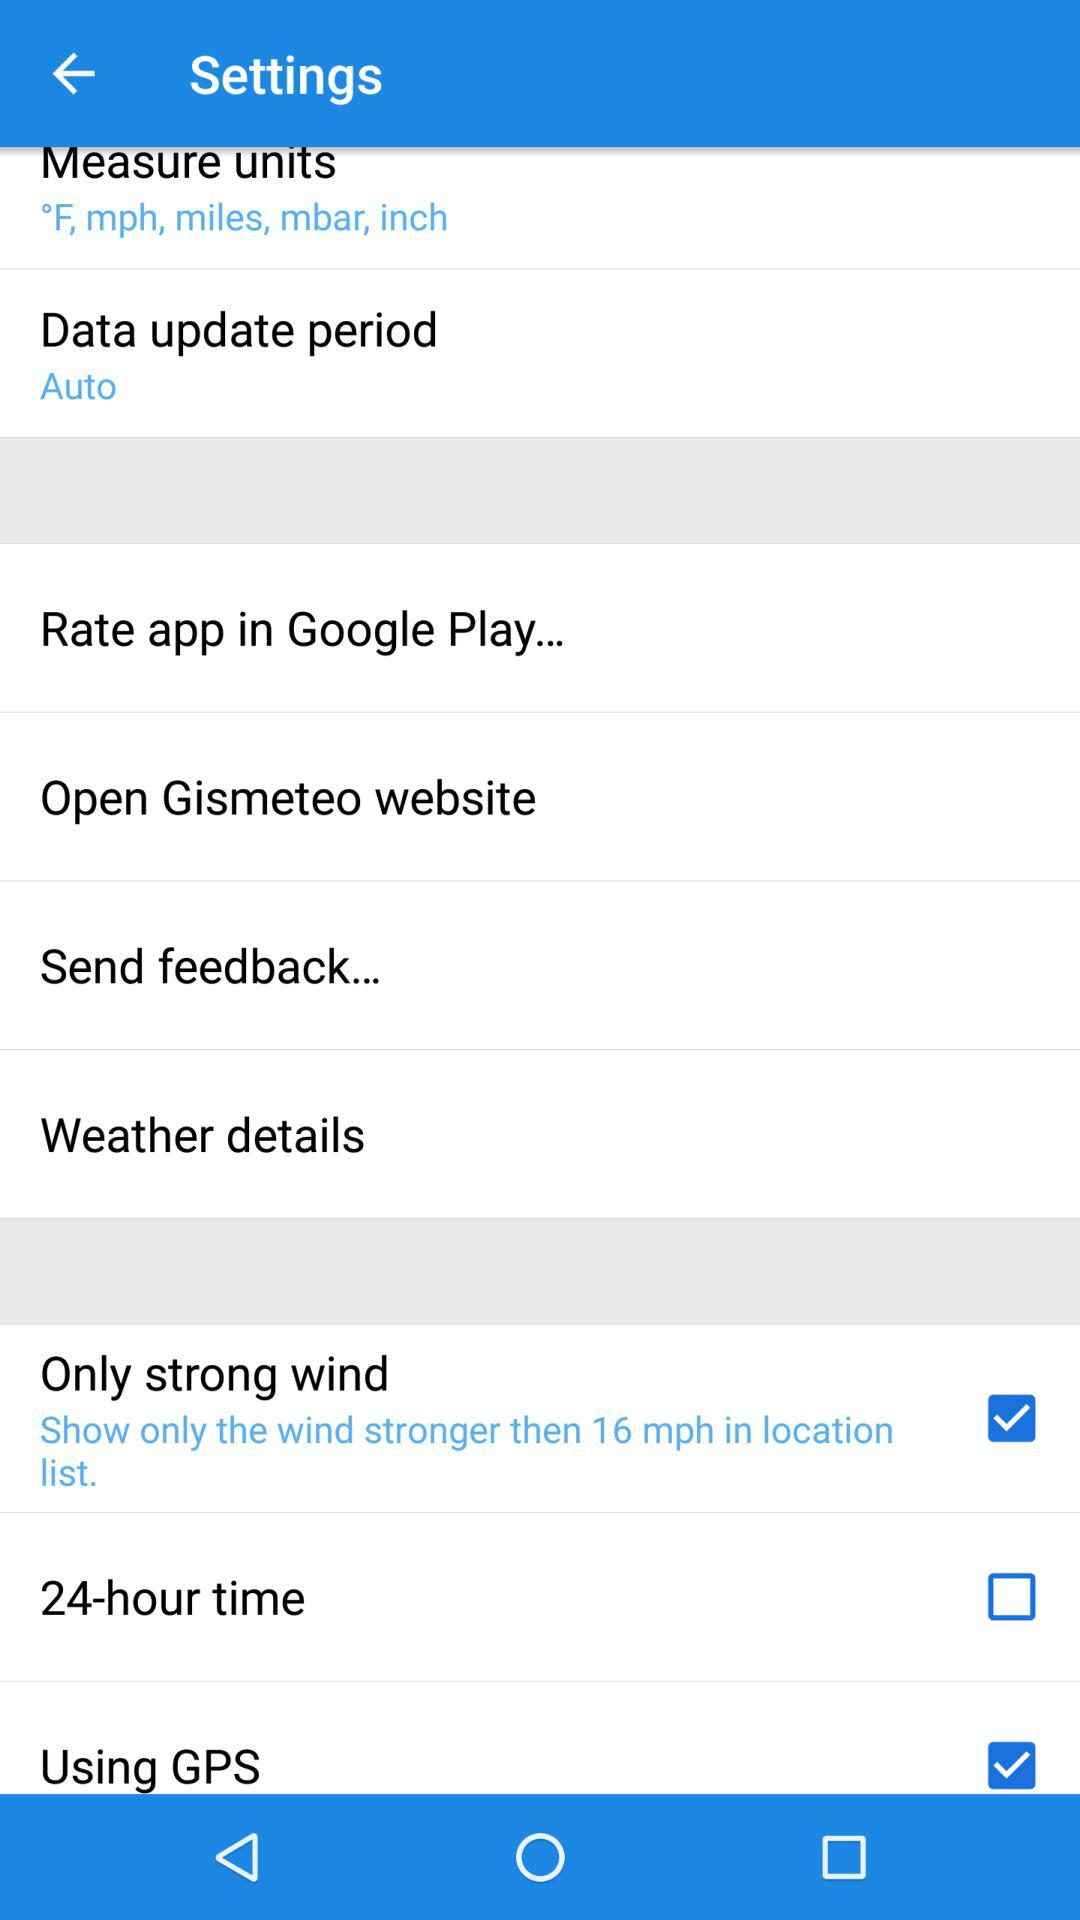Which options are selected in the setting? The options that are selected in the setting are "Only strong wind" and "Using GPS". 